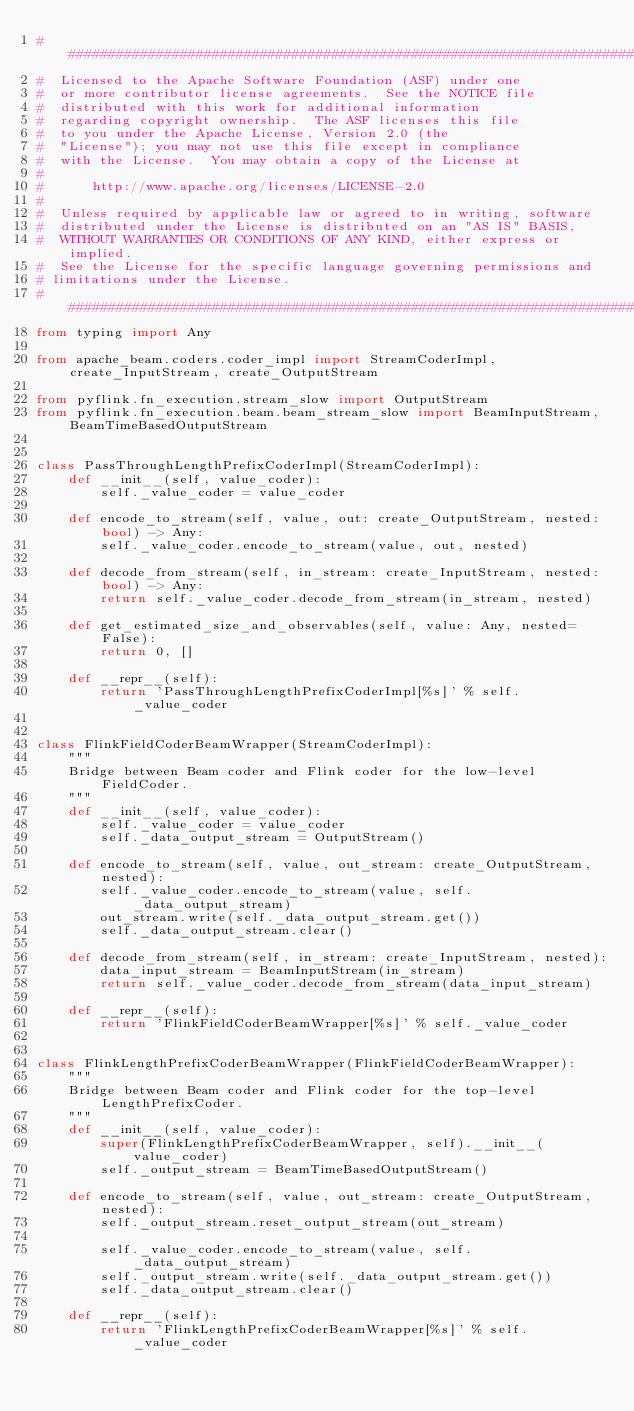Convert code to text. <code><loc_0><loc_0><loc_500><loc_500><_Python_>################################################################################
#  Licensed to the Apache Software Foundation (ASF) under one
#  or more contributor license agreements.  See the NOTICE file
#  distributed with this work for additional information
#  regarding copyright ownership.  The ASF licenses this file
#  to you under the Apache License, Version 2.0 (the
#  "License"); you may not use this file except in compliance
#  with the License.  You may obtain a copy of the License at
#
#      http://www.apache.org/licenses/LICENSE-2.0
#
#  Unless required by applicable law or agreed to in writing, software
#  distributed under the License is distributed on an "AS IS" BASIS,
#  WITHOUT WARRANTIES OR CONDITIONS OF ANY KIND, either express or implied.
#  See the License for the specific language governing permissions and
# limitations under the License.
################################################################################
from typing import Any

from apache_beam.coders.coder_impl import StreamCoderImpl, create_InputStream, create_OutputStream

from pyflink.fn_execution.stream_slow import OutputStream
from pyflink.fn_execution.beam.beam_stream_slow import BeamInputStream, BeamTimeBasedOutputStream


class PassThroughLengthPrefixCoderImpl(StreamCoderImpl):
    def __init__(self, value_coder):
        self._value_coder = value_coder

    def encode_to_stream(self, value, out: create_OutputStream, nested: bool) -> Any:
        self._value_coder.encode_to_stream(value, out, nested)

    def decode_from_stream(self, in_stream: create_InputStream, nested: bool) -> Any:
        return self._value_coder.decode_from_stream(in_stream, nested)

    def get_estimated_size_and_observables(self, value: Any, nested=False):
        return 0, []

    def __repr__(self):
        return 'PassThroughLengthPrefixCoderImpl[%s]' % self._value_coder


class FlinkFieldCoderBeamWrapper(StreamCoderImpl):
    """
    Bridge between Beam coder and Flink coder for the low-level FieldCoder.
    """
    def __init__(self, value_coder):
        self._value_coder = value_coder
        self._data_output_stream = OutputStream()

    def encode_to_stream(self, value, out_stream: create_OutputStream, nested):
        self._value_coder.encode_to_stream(value, self._data_output_stream)
        out_stream.write(self._data_output_stream.get())
        self._data_output_stream.clear()

    def decode_from_stream(self, in_stream: create_InputStream, nested):
        data_input_stream = BeamInputStream(in_stream)
        return self._value_coder.decode_from_stream(data_input_stream)

    def __repr__(self):
        return 'FlinkFieldCoderBeamWrapper[%s]' % self._value_coder


class FlinkLengthPrefixCoderBeamWrapper(FlinkFieldCoderBeamWrapper):
    """
    Bridge between Beam coder and Flink coder for the top-level LengthPrefixCoder.
    """
    def __init__(self, value_coder):
        super(FlinkLengthPrefixCoderBeamWrapper, self).__init__(value_coder)
        self._output_stream = BeamTimeBasedOutputStream()

    def encode_to_stream(self, value, out_stream: create_OutputStream, nested):
        self._output_stream.reset_output_stream(out_stream)

        self._value_coder.encode_to_stream(value, self._data_output_stream)
        self._output_stream.write(self._data_output_stream.get())
        self._data_output_stream.clear()

    def __repr__(self):
        return 'FlinkLengthPrefixCoderBeamWrapper[%s]' % self._value_coder
</code> 